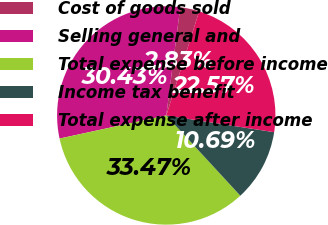Convert chart. <chart><loc_0><loc_0><loc_500><loc_500><pie_chart><fcel>Cost of goods sold<fcel>Selling general and<fcel>Total expense before income<fcel>Income tax benefit<fcel>Total expense after income<nl><fcel>2.83%<fcel>30.43%<fcel>33.47%<fcel>10.69%<fcel>22.57%<nl></chart> 